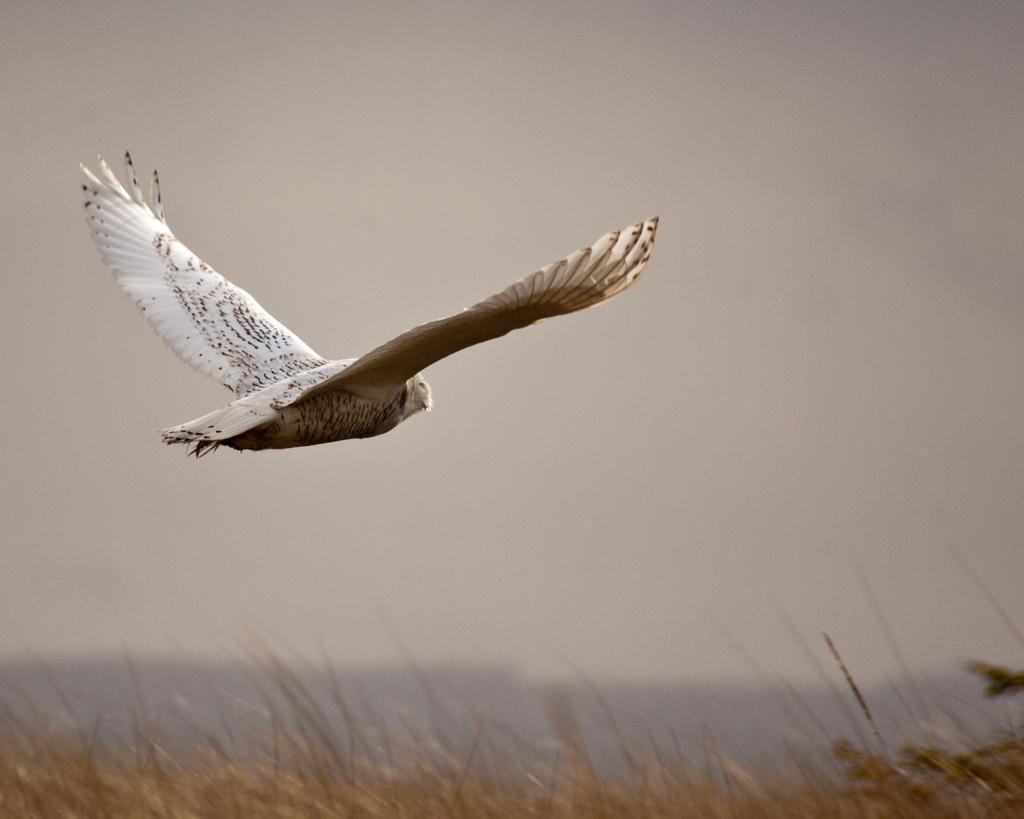Can you describe this image briefly? In this image we can see a bird which is in white color flying in the sky, we can see some plants and clear sky. 